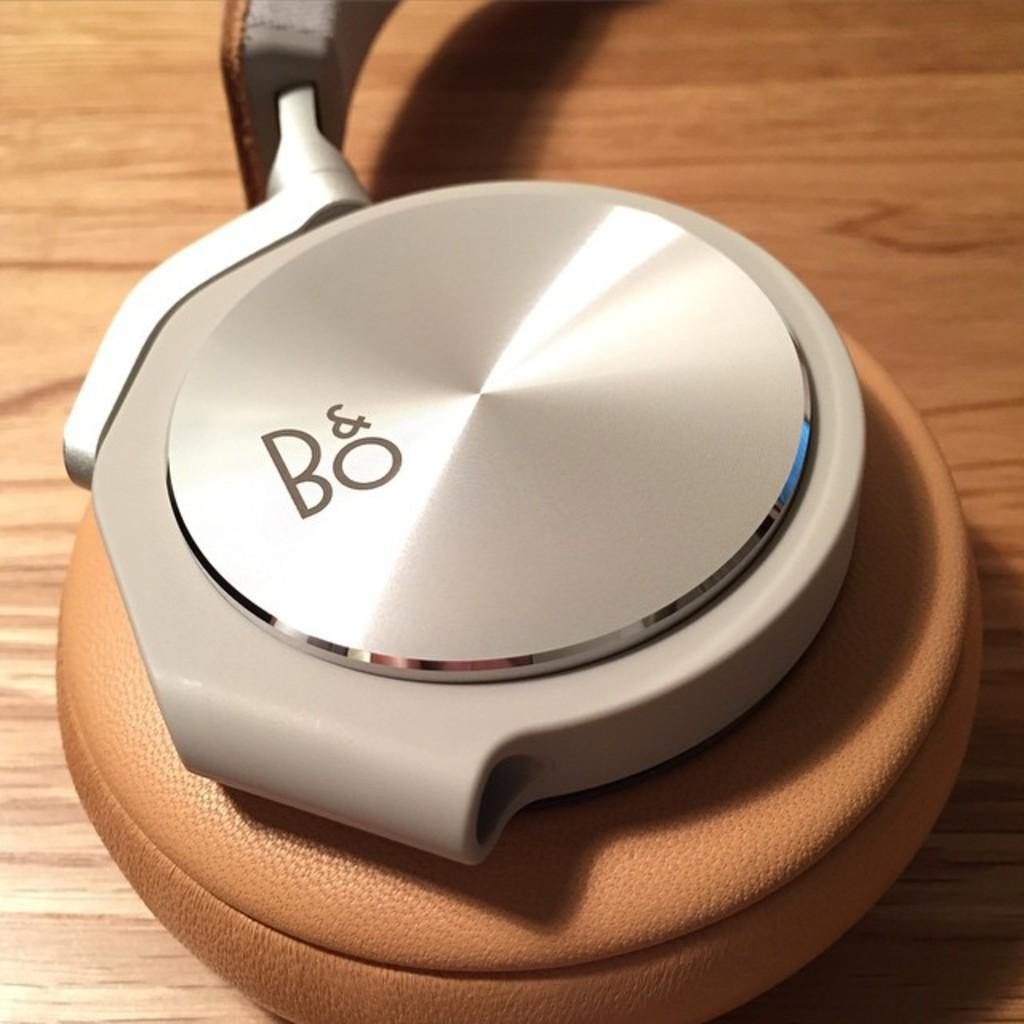<image>
Present a compact description of the photo's key features. A silver, white and brown object that is made by B&O. 